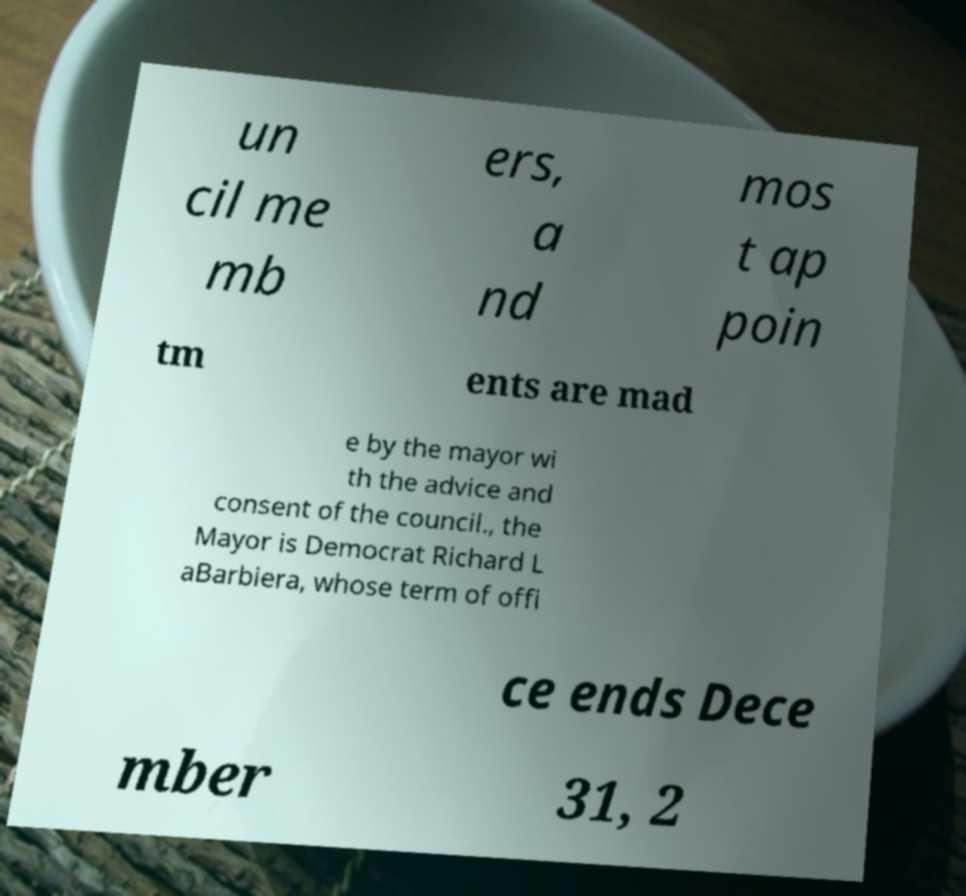Could you assist in decoding the text presented in this image and type it out clearly? un cil me mb ers, a nd mos t ap poin tm ents are mad e by the mayor wi th the advice and consent of the council., the Mayor is Democrat Richard L aBarbiera, whose term of offi ce ends Dece mber 31, 2 